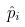<formula> <loc_0><loc_0><loc_500><loc_500>\hat { p } _ { i }</formula> 